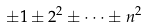Convert formula to latex. <formula><loc_0><loc_0><loc_500><loc_500>\pm 1 \pm 2 ^ { 2 } \pm \dots \pm n ^ { 2 }</formula> 